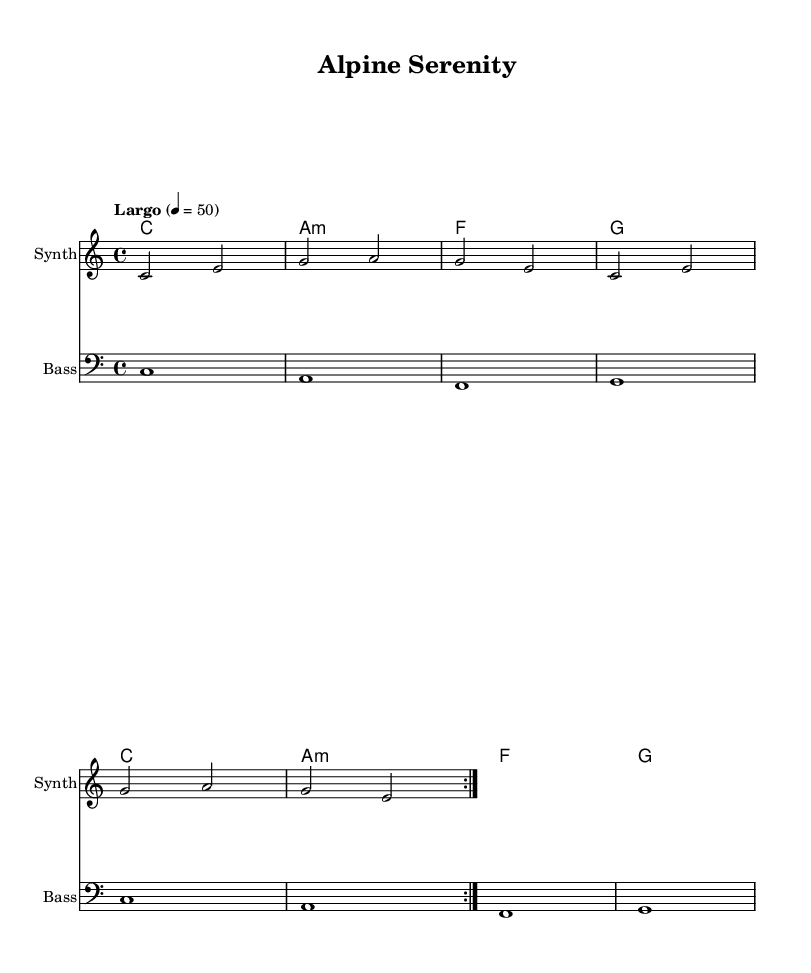What is the key signature of this music? The key signature is C major, which has no sharps or flats.
Answer: C major What is the time signature of the piece? The time signature is indicated at the beginning of the score and is 4/4, meaning there are four beats in each measure.
Answer: 4/4 What is the tempo marking given in the score? The tempo marking indicates the pace of the music as "Largo," which generally means slowly, and the specific tempo is set at 50 beats per minute.
Answer: Largo How many measures are in the melody section? The melody section consists of repeated sections, with a total of 4 measures presented when counted once, following the repeat markings.
Answer: 4 What instruments are designated in the score? The score specifies three distinct instrumental parts: Synth for the melody, Bass for the bass line, and it includes chord names, making it versatile for performance.
Answer: Synth, Bass Which chord is the first in the harmony section? The first chord in the harmony section is represented directly in the score as a C major chord, which is the foundation of the harmony throughout.
Answer: C How many times does the melody repeat? In the score, there is an explicit instruction to repeat the melody section twice, indicated by the repeat volta markings.
Answer: 2 